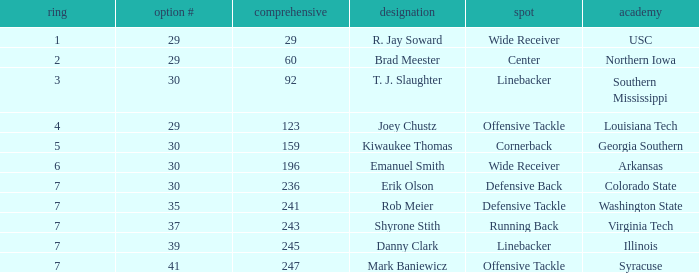What is the highest Pick that is wide receiver with overall of 29? 29.0. 